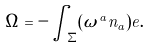Convert formula to latex. <formula><loc_0><loc_0><loc_500><loc_500>\Omega = - \int _ { \Sigma } ( \omega ^ { a } n _ { a } ) e .</formula> 